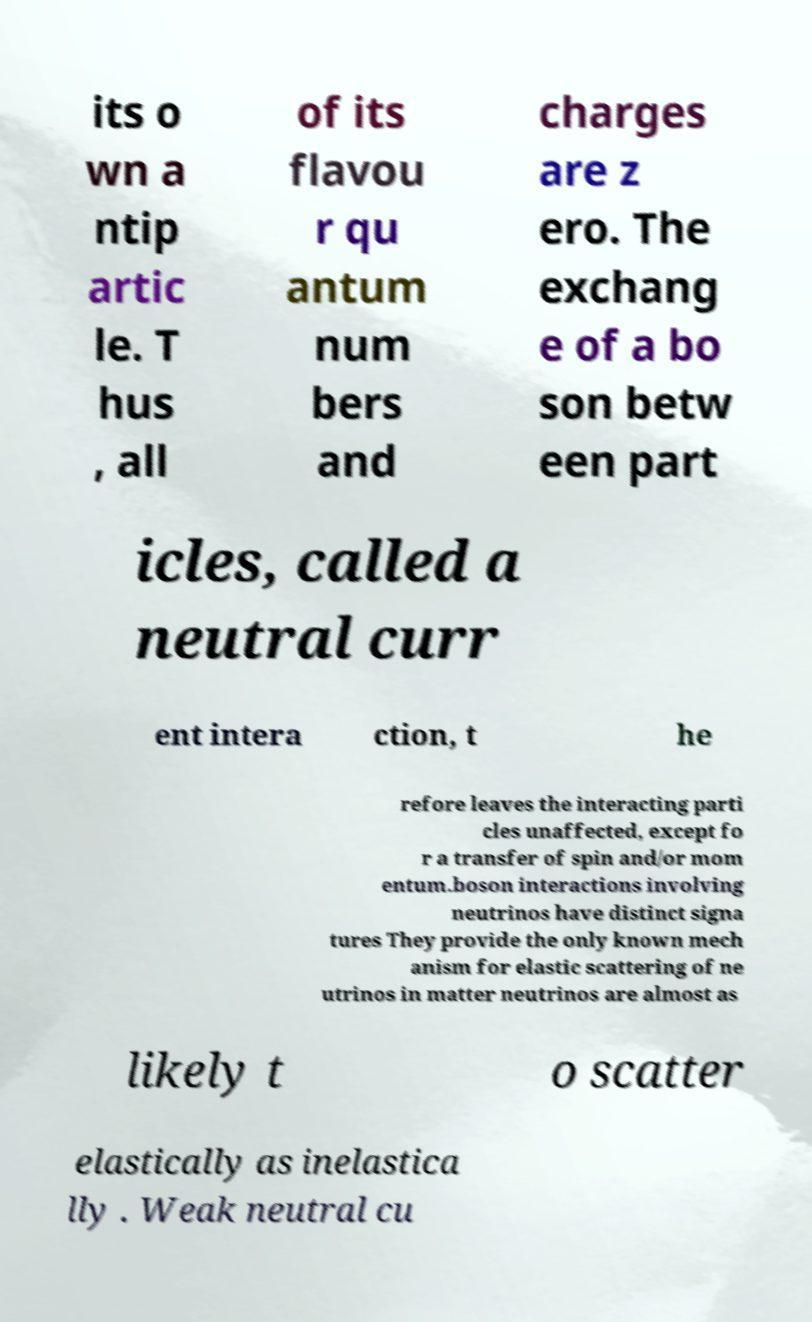What messages or text are displayed in this image? I need them in a readable, typed format. its o wn a ntip artic le. T hus , all of its flavou r qu antum num bers and charges are z ero. The exchang e of a bo son betw een part icles, called a neutral curr ent intera ction, t he refore leaves the interacting parti cles unaffected, except fo r a transfer of spin and/or mom entum.boson interactions involving neutrinos have distinct signa tures They provide the only known mech anism for elastic scattering of ne utrinos in matter neutrinos are almost as likely t o scatter elastically as inelastica lly . Weak neutral cu 